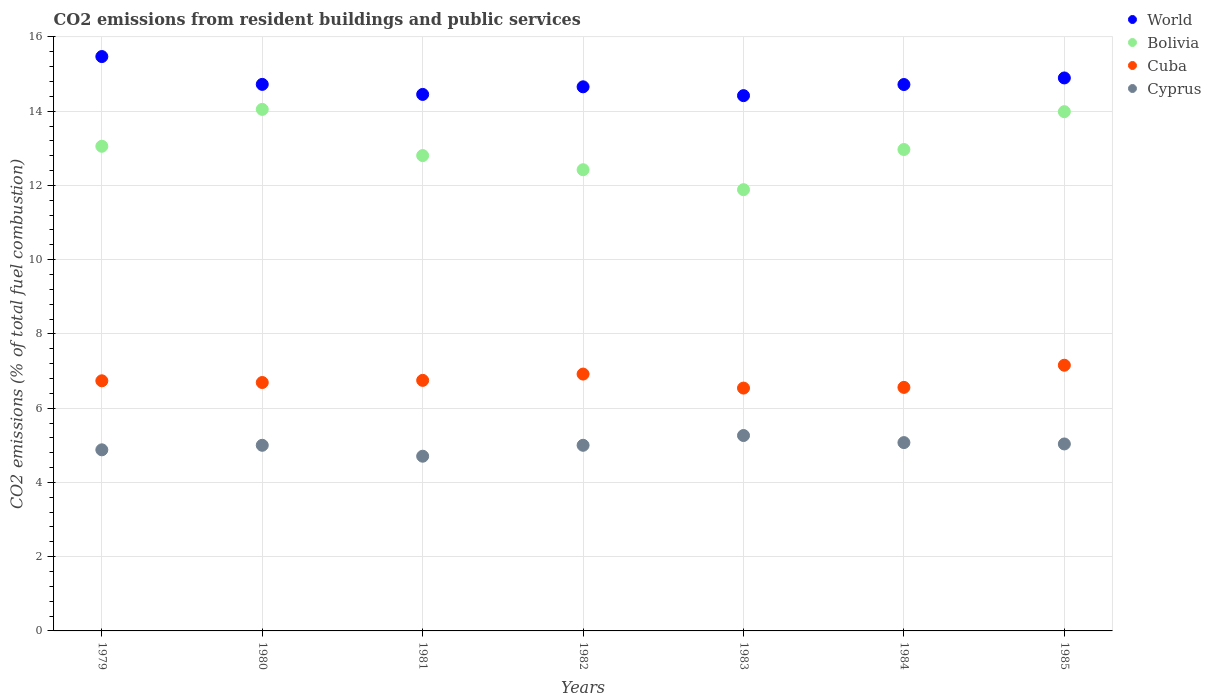Is the number of dotlines equal to the number of legend labels?
Give a very brief answer. Yes. What is the total CO2 emitted in Cyprus in 1982?
Provide a short and direct response. 5. Across all years, what is the maximum total CO2 emitted in Bolivia?
Offer a very short reply. 14.05. Across all years, what is the minimum total CO2 emitted in Cuba?
Provide a succinct answer. 6.54. In which year was the total CO2 emitted in Cyprus maximum?
Ensure brevity in your answer.  1983. What is the total total CO2 emitted in Bolivia in the graph?
Ensure brevity in your answer.  91.17. What is the difference between the total CO2 emitted in World in 1981 and that in 1983?
Your response must be concise. 0.03. What is the difference between the total CO2 emitted in Bolivia in 1985 and the total CO2 emitted in World in 1983?
Offer a terse response. -0.43. What is the average total CO2 emitted in Bolivia per year?
Your answer should be very brief. 13.02. In the year 1980, what is the difference between the total CO2 emitted in Bolivia and total CO2 emitted in World?
Ensure brevity in your answer.  -0.67. In how many years, is the total CO2 emitted in World greater than 5.2?
Your answer should be very brief. 7. What is the ratio of the total CO2 emitted in World in 1981 to that in 1985?
Keep it short and to the point. 0.97. What is the difference between the highest and the second highest total CO2 emitted in World?
Your response must be concise. 0.58. What is the difference between the highest and the lowest total CO2 emitted in Bolivia?
Offer a very short reply. 2.16. In how many years, is the total CO2 emitted in Bolivia greater than the average total CO2 emitted in Bolivia taken over all years?
Provide a succinct answer. 3. Is it the case that in every year, the sum of the total CO2 emitted in World and total CO2 emitted in Cyprus  is greater than the total CO2 emitted in Cuba?
Your answer should be compact. Yes. Does the total CO2 emitted in World monotonically increase over the years?
Keep it short and to the point. No. Is the total CO2 emitted in Cuba strictly less than the total CO2 emitted in Cyprus over the years?
Your answer should be compact. No. How many years are there in the graph?
Offer a very short reply. 7. What is the difference between two consecutive major ticks on the Y-axis?
Your answer should be very brief. 2. Where does the legend appear in the graph?
Your answer should be compact. Top right. What is the title of the graph?
Your response must be concise. CO2 emissions from resident buildings and public services. What is the label or title of the X-axis?
Ensure brevity in your answer.  Years. What is the label or title of the Y-axis?
Give a very brief answer. CO2 emissions (% of total fuel combustion). What is the CO2 emissions (% of total fuel combustion) of World in 1979?
Keep it short and to the point. 15.47. What is the CO2 emissions (% of total fuel combustion) in Bolivia in 1979?
Ensure brevity in your answer.  13.05. What is the CO2 emissions (% of total fuel combustion) in Cuba in 1979?
Give a very brief answer. 6.74. What is the CO2 emissions (% of total fuel combustion) of Cyprus in 1979?
Offer a terse response. 4.88. What is the CO2 emissions (% of total fuel combustion) in World in 1980?
Make the answer very short. 14.72. What is the CO2 emissions (% of total fuel combustion) of Bolivia in 1980?
Your response must be concise. 14.05. What is the CO2 emissions (% of total fuel combustion) in Cuba in 1980?
Your answer should be compact. 6.69. What is the CO2 emissions (% of total fuel combustion) in World in 1981?
Keep it short and to the point. 14.45. What is the CO2 emissions (% of total fuel combustion) of Bolivia in 1981?
Offer a terse response. 12.8. What is the CO2 emissions (% of total fuel combustion) in Cuba in 1981?
Ensure brevity in your answer.  6.75. What is the CO2 emissions (% of total fuel combustion) of Cyprus in 1981?
Your answer should be very brief. 4.71. What is the CO2 emissions (% of total fuel combustion) of World in 1982?
Give a very brief answer. 14.66. What is the CO2 emissions (% of total fuel combustion) of Bolivia in 1982?
Provide a short and direct response. 12.42. What is the CO2 emissions (% of total fuel combustion) of Cuba in 1982?
Your answer should be compact. 6.92. What is the CO2 emissions (% of total fuel combustion) of World in 1983?
Provide a short and direct response. 14.42. What is the CO2 emissions (% of total fuel combustion) in Bolivia in 1983?
Your response must be concise. 11.89. What is the CO2 emissions (% of total fuel combustion) of Cuba in 1983?
Your response must be concise. 6.54. What is the CO2 emissions (% of total fuel combustion) in Cyprus in 1983?
Your response must be concise. 5.26. What is the CO2 emissions (% of total fuel combustion) of World in 1984?
Your response must be concise. 14.72. What is the CO2 emissions (% of total fuel combustion) in Bolivia in 1984?
Ensure brevity in your answer.  12.97. What is the CO2 emissions (% of total fuel combustion) in Cuba in 1984?
Offer a terse response. 6.56. What is the CO2 emissions (% of total fuel combustion) of Cyprus in 1984?
Your response must be concise. 5.07. What is the CO2 emissions (% of total fuel combustion) in World in 1985?
Ensure brevity in your answer.  14.89. What is the CO2 emissions (% of total fuel combustion) of Bolivia in 1985?
Provide a succinct answer. 13.99. What is the CO2 emissions (% of total fuel combustion) of Cuba in 1985?
Give a very brief answer. 7.16. What is the CO2 emissions (% of total fuel combustion) in Cyprus in 1985?
Give a very brief answer. 5.04. Across all years, what is the maximum CO2 emissions (% of total fuel combustion) in World?
Give a very brief answer. 15.47. Across all years, what is the maximum CO2 emissions (% of total fuel combustion) in Bolivia?
Offer a very short reply. 14.05. Across all years, what is the maximum CO2 emissions (% of total fuel combustion) in Cuba?
Your answer should be compact. 7.16. Across all years, what is the maximum CO2 emissions (% of total fuel combustion) in Cyprus?
Provide a succinct answer. 5.26. Across all years, what is the minimum CO2 emissions (% of total fuel combustion) of World?
Give a very brief answer. 14.42. Across all years, what is the minimum CO2 emissions (% of total fuel combustion) in Bolivia?
Make the answer very short. 11.89. Across all years, what is the minimum CO2 emissions (% of total fuel combustion) in Cuba?
Make the answer very short. 6.54. Across all years, what is the minimum CO2 emissions (% of total fuel combustion) of Cyprus?
Make the answer very short. 4.71. What is the total CO2 emissions (% of total fuel combustion) in World in the graph?
Give a very brief answer. 103.33. What is the total CO2 emissions (% of total fuel combustion) of Bolivia in the graph?
Give a very brief answer. 91.17. What is the total CO2 emissions (% of total fuel combustion) of Cuba in the graph?
Ensure brevity in your answer.  47.35. What is the total CO2 emissions (% of total fuel combustion) in Cyprus in the graph?
Provide a succinct answer. 34.96. What is the difference between the CO2 emissions (% of total fuel combustion) in World in 1979 and that in 1980?
Give a very brief answer. 0.75. What is the difference between the CO2 emissions (% of total fuel combustion) in Bolivia in 1979 and that in 1980?
Provide a short and direct response. -0.99. What is the difference between the CO2 emissions (% of total fuel combustion) in Cuba in 1979 and that in 1980?
Your answer should be very brief. 0.05. What is the difference between the CO2 emissions (% of total fuel combustion) in Cyprus in 1979 and that in 1980?
Your answer should be very brief. -0.12. What is the difference between the CO2 emissions (% of total fuel combustion) of World in 1979 and that in 1981?
Your answer should be very brief. 1.02. What is the difference between the CO2 emissions (% of total fuel combustion) in Bolivia in 1979 and that in 1981?
Offer a very short reply. 0.25. What is the difference between the CO2 emissions (% of total fuel combustion) in Cuba in 1979 and that in 1981?
Ensure brevity in your answer.  -0.01. What is the difference between the CO2 emissions (% of total fuel combustion) of Cyprus in 1979 and that in 1981?
Ensure brevity in your answer.  0.17. What is the difference between the CO2 emissions (% of total fuel combustion) in World in 1979 and that in 1982?
Offer a very short reply. 0.82. What is the difference between the CO2 emissions (% of total fuel combustion) in Bolivia in 1979 and that in 1982?
Provide a short and direct response. 0.63. What is the difference between the CO2 emissions (% of total fuel combustion) in Cuba in 1979 and that in 1982?
Offer a very short reply. -0.18. What is the difference between the CO2 emissions (% of total fuel combustion) of Cyprus in 1979 and that in 1982?
Offer a terse response. -0.12. What is the difference between the CO2 emissions (% of total fuel combustion) of World in 1979 and that in 1983?
Your answer should be compact. 1.05. What is the difference between the CO2 emissions (% of total fuel combustion) in Bolivia in 1979 and that in 1983?
Your answer should be compact. 1.17. What is the difference between the CO2 emissions (% of total fuel combustion) of Cuba in 1979 and that in 1983?
Provide a short and direct response. 0.2. What is the difference between the CO2 emissions (% of total fuel combustion) in Cyprus in 1979 and that in 1983?
Offer a terse response. -0.39. What is the difference between the CO2 emissions (% of total fuel combustion) in World in 1979 and that in 1984?
Offer a very short reply. 0.75. What is the difference between the CO2 emissions (% of total fuel combustion) in Bolivia in 1979 and that in 1984?
Offer a terse response. 0.09. What is the difference between the CO2 emissions (% of total fuel combustion) of Cuba in 1979 and that in 1984?
Give a very brief answer. 0.18. What is the difference between the CO2 emissions (% of total fuel combustion) in Cyprus in 1979 and that in 1984?
Give a very brief answer. -0.19. What is the difference between the CO2 emissions (% of total fuel combustion) in World in 1979 and that in 1985?
Make the answer very short. 0.58. What is the difference between the CO2 emissions (% of total fuel combustion) in Bolivia in 1979 and that in 1985?
Give a very brief answer. -0.93. What is the difference between the CO2 emissions (% of total fuel combustion) of Cuba in 1979 and that in 1985?
Offer a very short reply. -0.42. What is the difference between the CO2 emissions (% of total fuel combustion) of Cyprus in 1979 and that in 1985?
Make the answer very short. -0.16. What is the difference between the CO2 emissions (% of total fuel combustion) in World in 1980 and that in 1981?
Provide a succinct answer. 0.27. What is the difference between the CO2 emissions (% of total fuel combustion) of Bolivia in 1980 and that in 1981?
Your answer should be very brief. 1.24. What is the difference between the CO2 emissions (% of total fuel combustion) of Cuba in 1980 and that in 1981?
Offer a terse response. -0.06. What is the difference between the CO2 emissions (% of total fuel combustion) in Cyprus in 1980 and that in 1981?
Your answer should be compact. 0.29. What is the difference between the CO2 emissions (% of total fuel combustion) of World in 1980 and that in 1982?
Ensure brevity in your answer.  0.07. What is the difference between the CO2 emissions (% of total fuel combustion) in Bolivia in 1980 and that in 1982?
Keep it short and to the point. 1.63. What is the difference between the CO2 emissions (% of total fuel combustion) of Cuba in 1980 and that in 1982?
Give a very brief answer. -0.23. What is the difference between the CO2 emissions (% of total fuel combustion) in World in 1980 and that in 1983?
Keep it short and to the point. 0.3. What is the difference between the CO2 emissions (% of total fuel combustion) in Bolivia in 1980 and that in 1983?
Provide a short and direct response. 2.16. What is the difference between the CO2 emissions (% of total fuel combustion) in Cyprus in 1980 and that in 1983?
Keep it short and to the point. -0.26. What is the difference between the CO2 emissions (% of total fuel combustion) of World in 1980 and that in 1984?
Your answer should be compact. 0. What is the difference between the CO2 emissions (% of total fuel combustion) in Bolivia in 1980 and that in 1984?
Offer a very short reply. 1.08. What is the difference between the CO2 emissions (% of total fuel combustion) of Cuba in 1980 and that in 1984?
Your answer should be very brief. 0.13. What is the difference between the CO2 emissions (% of total fuel combustion) of Cyprus in 1980 and that in 1984?
Your answer should be very brief. -0.07. What is the difference between the CO2 emissions (% of total fuel combustion) of World in 1980 and that in 1985?
Ensure brevity in your answer.  -0.17. What is the difference between the CO2 emissions (% of total fuel combustion) in Bolivia in 1980 and that in 1985?
Keep it short and to the point. 0.06. What is the difference between the CO2 emissions (% of total fuel combustion) in Cuba in 1980 and that in 1985?
Your answer should be very brief. -0.47. What is the difference between the CO2 emissions (% of total fuel combustion) in Cyprus in 1980 and that in 1985?
Provide a succinct answer. -0.04. What is the difference between the CO2 emissions (% of total fuel combustion) of World in 1981 and that in 1982?
Offer a terse response. -0.2. What is the difference between the CO2 emissions (% of total fuel combustion) of Bolivia in 1981 and that in 1982?
Provide a succinct answer. 0.38. What is the difference between the CO2 emissions (% of total fuel combustion) in Cuba in 1981 and that in 1982?
Make the answer very short. -0.17. What is the difference between the CO2 emissions (% of total fuel combustion) in Cyprus in 1981 and that in 1982?
Keep it short and to the point. -0.29. What is the difference between the CO2 emissions (% of total fuel combustion) of World in 1981 and that in 1983?
Provide a short and direct response. 0.03. What is the difference between the CO2 emissions (% of total fuel combustion) in Bolivia in 1981 and that in 1983?
Your answer should be very brief. 0.92. What is the difference between the CO2 emissions (% of total fuel combustion) in Cuba in 1981 and that in 1983?
Give a very brief answer. 0.21. What is the difference between the CO2 emissions (% of total fuel combustion) in Cyprus in 1981 and that in 1983?
Offer a very short reply. -0.56. What is the difference between the CO2 emissions (% of total fuel combustion) in World in 1981 and that in 1984?
Your response must be concise. -0.27. What is the difference between the CO2 emissions (% of total fuel combustion) of Bolivia in 1981 and that in 1984?
Provide a succinct answer. -0.16. What is the difference between the CO2 emissions (% of total fuel combustion) of Cuba in 1981 and that in 1984?
Offer a very short reply. 0.19. What is the difference between the CO2 emissions (% of total fuel combustion) in Cyprus in 1981 and that in 1984?
Your answer should be compact. -0.37. What is the difference between the CO2 emissions (% of total fuel combustion) in World in 1981 and that in 1985?
Ensure brevity in your answer.  -0.44. What is the difference between the CO2 emissions (% of total fuel combustion) in Bolivia in 1981 and that in 1985?
Give a very brief answer. -1.18. What is the difference between the CO2 emissions (% of total fuel combustion) in Cuba in 1981 and that in 1985?
Keep it short and to the point. -0.41. What is the difference between the CO2 emissions (% of total fuel combustion) of Cyprus in 1981 and that in 1985?
Provide a succinct answer. -0.33. What is the difference between the CO2 emissions (% of total fuel combustion) in World in 1982 and that in 1983?
Offer a very short reply. 0.24. What is the difference between the CO2 emissions (% of total fuel combustion) in Bolivia in 1982 and that in 1983?
Make the answer very short. 0.54. What is the difference between the CO2 emissions (% of total fuel combustion) in Cuba in 1982 and that in 1983?
Offer a very short reply. 0.38. What is the difference between the CO2 emissions (% of total fuel combustion) of Cyprus in 1982 and that in 1983?
Provide a succinct answer. -0.26. What is the difference between the CO2 emissions (% of total fuel combustion) of World in 1982 and that in 1984?
Offer a very short reply. -0.06. What is the difference between the CO2 emissions (% of total fuel combustion) in Bolivia in 1982 and that in 1984?
Make the answer very short. -0.54. What is the difference between the CO2 emissions (% of total fuel combustion) of Cuba in 1982 and that in 1984?
Provide a succinct answer. 0.36. What is the difference between the CO2 emissions (% of total fuel combustion) of Cyprus in 1982 and that in 1984?
Provide a short and direct response. -0.07. What is the difference between the CO2 emissions (% of total fuel combustion) in World in 1982 and that in 1985?
Offer a terse response. -0.24. What is the difference between the CO2 emissions (% of total fuel combustion) of Bolivia in 1982 and that in 1985?
Your response must be concise. -1.56. What is the difference between the CO2 emissions (% of total fuel combustion) of Cuba in 1982 and that in 1985?
Provide a short and direct response. -0.24. What is the difference between the CO2 emissions (% of total fuel combustion) of Cyprus in 1982 and that in 1985?
Provide a succinct answer. -0.04. What is the difference between the CO2 emissions (% of total fuel combustion) of World in 1983 and that in 1984?
Your answer should be very brief. -0.3. What is the difference between the CO2 emissions (% of total fuel combustion) of Bolivia in 1983 and that in 1984?
Ensure brevity in your answer.  -1.08. What is the difference between the CO2 emissions (% of total fuel combustion) in Cuba in 1983 and that in 1984?
Your answer should be compact. -0.02. What is the difference between the CO2 emissions (% of total fuel combustion) in Cyprus in 1983 and that in 1984?
Offer a very short reply. 0.19. What is the difference between the CO2 emissions (% of total fuel combustion) in World in 1983 and that in 1985?
Offer a terse response. -0.48. What is the difference between the CO2 emissions (% of total fuel combustion) of Bolivia in 1983 and that in 1985?
Keep it short and to the point. -2.1. What is the difference between the CO2 emissions (% of total fuel combustion) of Cuba in 1983 and that in 1985?
Keep it short and to the point. -0.62. What is the difference between the CO2 emissions (% of total fuel combustion) of Cyprus in 1983 and that in 1985?
Ensure brevity in your answer.  0.23. What is the difference between the CO2 emissions (% of total fuel combustion) in World in 1984 and that in 1985?
Offer a terse response. -0.18. What is the difference between the CO2 emissions (% of total fuel combustion) of Bolivia in 1984 and that in 1985?
Keep it short and to the point. -1.02. What is the difference between the CO2 emissions (% of total fuel combustion) in Cuba in 1984 and that in 1985?
Provide a short and direct response. -0.6. What is the difference between the CO2 emissions (% of total fuel combustion) in Cyprus in 1984 and that in 1985?
Offer a terse response. 0.04. What is the difference between the CO2 emissions (% of total fuel combustion) of World in 1979 and the CO2 emissions (% of total fuel combustion) of Bolivia in 1980?
Ensure brevity in your answer.  1.42. What is the difference between the CO2 emissions (% of total fuel combustion) of World in 1979 and the CO2 emissions (% of total fuel combustion) of Cuba in 1980?
Your answer should be very brief. 8.78. What is the difference between the CO2 emissions (% of total fuel combustion) of World in 1979 and the CO2 emissions (% of total fuel combustion) of Cyprus in 1980?
Give a very brief answer. 10.47. What is the difference between the CO2 emissions (% of total fuel combustion) in Bolivia in 1979 and the CO2 emissions (% of total fuel combustion) in Cuba in 1980?
Provide a short and direct response. 6.36. What is the difference between the CO2 emissions (% of total fuel combustion) of Bolivia in 1979 and the CO2 emissions (% of total fuel combustion) of Cyprus in 1980?
Your response must be concise. 8.05. What is the difference between the CO2 emissions (% of total fuel combustion) of Cuba in 1979 and the CO2 emissions (% of total fuel combustion) of Cyprus in 1980?
Keep it short and to the point. 1.74. What is the difference between the CO2 emissions (% of total fuel combustion) of World in 1979 and the CO2 emissions (% of total fuel combustion) of Bolivia in 1981?
Make the answer very short. 2.67. What is the difference between the CO2 emissions (% of total fuel combustion) in World in 1979 and the CO2 emissions (% of total fuel combustion) in Cuba in 1981?
Make the answer very short. 8.72. What is the difference between the CO2 emissions (% of total fuel combustion) of World in 1979 and the CO2 emissions (% of total fuel combustion) of Cyprus in 1981?
Make the answer very short. 10.76. What is the difference between the CO2 emissions (% of total fuel combustion) in Bolivia in 1979 and the CO2 emissions (% of total fuel combustion) in Cuba in 1981?
Your answer should be compact. 6.31. What is the difference between the CO2 emissions (% of total fuel combustion) of Bolivia in 1979 and the CO2 emissions (% of total fuel combustion) of Cyprus in 1981?
Your answer should be compact. 8.35. What is the difference between the CO2 emissions (% of total fuel combustion) in Cuba in 1979 and the CO2 emissions (% of total fuel combustion) in Cyprus in 1981?
Provide a short and direct response. 2.03. What is the difference between the CO2 emissions (% of total fuel combustion) of World in 1979 and the CO2 emissions (% of total fuel combustion) of Bolivia in 1982?
Your answer should be compact. 3.05. What is the difference between the CO2 emissions (% of total fuel combustion) of World in 1979 and the CO2 emissions (% of total fuel combustion) of Cuba in 1982?
Keep it short and to the point. 8.55. What is the difference between the CO2 emissions (% of total fuel combustion) of World in 1979 and the CO2 emissions (% of total fuel combustion) of Cyprus in 1982?
Make the answer very short. 10.47. What is the difference between the CO2 emissions (% of total fuel combustion) in Bolivia in 1979 and the CO2 emissions (% of total fuel combustion) in Cuba in 1982?
Offer a very short reply. 6.14. What is the difference between the CO2 emissions (% of total fuel combustion) in Bolivia in 1979 and the CO2 emissions (% of total fuel combustion) in Cyprus in 1982?
Make the answer very short. 8.05. What is the difference between the CO2 emissions (% of total fuel combustion) of Cuba in 1979 and the CO2 emissions (% of total fuel combustion) of Cyprus in 1982?
Your answer should be very brief. 1.74. What is the difference between the CO2 emissions (% of total fuel combustion) in World in 1979 and the CO2 emissions (% of total fuel combustion) in Bolivia in 1983?
Keep it short and to the point. 3.59. What is the difference between the CO2 emissions (% of total fuel combustion) of World in 1979 and the CO2 emissions (% of total fuel combustion) of Cuba in 1983?
Offer a very short reply. 8.93. What is the difference between the CO2 emissions (% of total fuel combustion) in World in 1979 and the CO2 emissions (% of total fuel combustion) in Cyprus in 1983?
Your answer should be very brief. 10.21. What is the difference between the CO2 emissions (% of total fuel combustion) of Bolivia in 1979 and the CO2 emissions (% of total fuel combustion) of Cuba in 1983?
Keep it short and to the point. 6.51. What is the difference between the CO2 emissions (% of total fuel combustion) in Bolivia in 1979 and the CO2 emissions (% of total fuel combustion) in Cyprus in 1983?
Your answer should be compact. 7.79. What is the difference between the CO2 emissions (% of total fuel combustion) in Cuba in 1979 and the CO2 emissions (% of total fuel combustion) in Cyprus in 1983?
Offer a terse response. 1.47. What is the difference between the CO2 emissions (% of total fuel combustion) in World in 1979 and the CO2 emissions (% of total fuel combustion) in Bolivia in 1984?
Provide a short and direct response. 2.5. What is the difference between the CO2 emissions (% of total fuel combustion) of World in 1979 and the CO2 emissions (% of total fuel combustion) of Cuba in 1984?
Provide a short and direct response. 8.91. What is the difference between the CO2 emissions (% of total fuel combustion) of World in 1979 and the CO2 emissions (% of total fuel combustion) of Cyprus in 1984?
Keep it short and to the point. 10.4. What is the difference between the CO2 emissions (% of total fuel combustion) in Bolivia in 1979 and the CO2 emissions (% of total fuel combustion) in Cuba in 1984?
Offer a very short reply. 6.49. What is the difference between the CO2 emissions (% of total fuel combustion) of Bolivia in 1979 and the CO2 emissions (% of total fuel combustion) of Cyprus in 1984?
Your answer should be very brief. 7.98. What is the difference between the CO2 emissions (% of total fuel combustion) of Cuba in 1979 and the CO2 emissions (% of total fuel combustion) of Cyprus in 1984?
Your answer should be very brief. 1.66. What is the difference between the CO2 emissions (% of total fuel combustion) of World in 1979 and the CO2 emissions (% of total fuel combustion) of Bolivia in 1985?
Keep it short and to the point. 1.48. What is the difference between the CO2 emissions (% of total fuel combustion) of World in 1979 and the CO2 emissions (% of total fuel combustion) of Cuba in 1985?
Your answer should be very brief. 8.31. What is the difference between the CO2 emissions (% of total fuel combustion) of World in 1979 and the CO2 emissions (% of total fuel combustion) of Cyprus in 1985?
Make the answer very short. 10.43. What is the difference between the CO2 emissions (% of total fuel combustion) in Bolivia in 1979 and the CO2 emissions (% of total fuel combustion) in Cuba in 1985?
Your response must be concise. 5.9. What is the difference between the CO2 emissions (% of total fuel combustion) of Bolivia in 1979 and the CO2 emissions (% of total fuel combustion) of Cyprus in 1985?
Provide a short and direct response. 8.02. What is the difference between the CO2 emissions (% of total fuel combustion) in Cuba in 1979 and the CO2 emissions (% of total fuel combustion) in Cyprus in 1985?
Your answer should be very brief. 1.7. What is the difference between the CO2 emissions (% of total fuel combustion) of World in 1980 and the CO2 emissions (% of total fuel combustion) of Bolivia in 1981?
Provide a short and direct response. 1.92. What is the difference between the CO2 emissions (% of total fuel combustion) of World in 1980 and the CO2 emissions (% of total fuel combustion) of Cuba in 1981?
Give a very brief answer. 7.97. What is the difference between the CO2 emissions (% of total fuel combustion) of World in 1980 and the CO2 emissions (% of total fuel combustion) of Cyprus in 1981?
Offer a terse response. 10.02. What is the difference between the CO2 emissions (% of total fuel combustion) of Bolivia in 1980 and the CO2 emissions (% of total fuel combustion) of Cuba in 1981?
Give a very brief answer. 7.3. What is the difference between the CO2 emissions (% of total fuel combustion) in Bolivia in 1980 and the CO2 emissions (% of total fuel combustion) in Cyprus in 1981?
Offer a very short reply. 9.34. What is the difference between the CO2 emissions (% of total fuel combustion) of Cuba in 1980 and the CO2 emissions (% of total fuel combustion) of Cyprus in 1981?
Offer a terse response. 1.99. What is the difference between the CO2 emissions (% of total fuel combustion) of World in 1980 and the CO2 emissions (% of total fuel combustion) of Bolivia in 1982?
Give a very brief answer. 2.3. What is the difference between the CO2 emissions (% of total fuel combustion) in World in 1980 and the CO2 emissions (% of total fuel combustion) in Cuba in 1982?
Provide a succinct answer. 7.8. What is the difference between the CO2 emissions (% of total fuel combustion) of World in 1980 and the CO2 emissions (% of total fuel combustion) of Cyprus in 1982?
Make the answer very short. 9.72. What is the difference between the CO2 emissions (% of total fuel combustion) of Bolivia in 1980 and the CO2 emissions (% of total fuel combustion) of Cuba in 1982?
Your answer should be compact. 7.13. What is the difference between the CO2 emissions (% of total fuel combustion) of Bolivia in 1980 and the CO2 emissions (% of total fuel combustion) of Cyprus in 1982?
Offer a terse response. 9.05. What is the difference between the CO2 emissions (% of total fuel combustion) of Cuba in 1980 and the CO2 emissions (% of total fuel combustion) of Cyprus in 1982?
Provide a short and direct response. 1.69. What is the difference between the CO2 emissions (% of total fuel combustion) in World in 1980 and the CO2 emissions (% of total fuel combustion) in Bolivia in 1983?
Provide a short and direct response. 2.84. What is the difference between the CO2 emissions (% of total fuel combustion) in World in 1980 and the CO2 emissions (% of total fuel combustion) in Cuba in 1983?
Ensure brevity in your answer.  8.18. What is the difference between the CO2 emissions (% of total fuel combustion) in World in 1980 and the CO2 emissions (% of total fuel combustion) in Cyprus in 1983?
Your response must be concise. 9.46. What is the difference between the CO2 emissions (% of total fuel combustion) of Bolivia in 1980 and the CO2 emissions (% of total fuel combustion) of Cuba in 1983?
Your answer should be very brief. 7.51. What is the difference between the CO2 emissions (% of total fuel combustion) of Bolivia in 1980 and the CO2 emissions (% of total fuel combustion) of Cyprus in 1983?
Provide a short and direct response. 8.78. What is the difference between the CO2 emissions (% of total fuel combustion) in Cuba in 1980 and the CO2 emissions (% of total fuel combustion) in Cyprus in 1983?
Your answer should be very brief. 1.43. What is the difference between the CO2 emissions (% of total fuel combustion) in World in 1980 and the CO2 emissions (% of total fuel combustion) in Bolivia in 1984?
Make the answer very short. 1.75. What is the difference between the CO2 emissions (% of total fuel combustion) in World in 1980 and the CO2 emissions (% of total fuel combustion) in Cuba in 1984?
Your answer should be compact. 8.16. What is the difference between the CO2 emissions (% of total fuel combustion) of World in 1980 and the CO2 emissions (% of total fuel combustion) of Cyprus in 1984?
Ensure brevity in your answer.  9.65. What is the difference between the CO2 emissions (% of total fuel combustion) in Bolivia in 1980 and the CO2 emissions (% of total fuel combustion) in Cuba in 1984?
Keep it short and to the point. 7.49. What is the difference between the CO2 emissions (% of total fuel combustion) of Bolivia in 1980 and the CO2 emissions (% of total fuel combustion) of Cyprus in 1984?
Give a very brief answer. 8.98. What is the difference between the CO2 emissions (% of total fuel combustion) in Cuba in 1980 and the CO2 emissions (% of total fuel combustion) in Cyprus in 1984?
Offer a terse response. 1.62. What is the difference between the CO2 emissions (% of total fuel combustion) of World in 1980 and the CO2 emissions (% of total fuel combustion) of Bolivia in 1985?
Keep it short and to the point. 0.74. What is the difference between the CO2 emissions (% of total fuel combustion) in World in 1980 and the CO2 emissions (% of total fuel combustion) in Cuba in 1985?
Offer a terse response. 7.57. What is the difference between the CO2 emissions (% of total fuel combustion) of World in 1980 and the CO2 emissions (% of total fuel combustion) of Cyprus in 1985?
Ensure brevity in your answer.  9.69. What is the difference between the CO2 emissions (% of total fuel combustion) in Bolivia in 1980 and the CO2 emissions (% of total fuel combustion) in Cuba in 1985?
Offer a terse response. 6.89. What is the difference between the CO2 emissions (% of total fuel combustion) in Bolivia in 1980 and the CO2 emissions (% of total fuel combustion) in Cyprus in 1985?
Your answer should be very brief. 9.01. What is the difference between the CO2 emissions (% of total fuel combustion) in Cuba in 1980 and the CO2 emissions (% of total fuel combustion) in Cyprus in 1985?
Provide a short and direct response. 1.66. What is the difference between the CO2 emissions (% of total fuel combustion) in World in 1981 and the CO2 emissions (% of total fuel combustion) in Bolivia in 1982?
Your answer should be very brief. 2.03. What is the difference between the CO2 emissions (% of total fuel combustion) of World in 1981 and the CO2 emissions (% of total fuel combustion) of Cuba in 1982?
Give a very brief answer. 7.53. What is the difference between the CO2 emissions (% of total fuel combustion) in World in 1981 and the CO2 emissions (% of total fuel combustion) in Cyprus in 1982?
Ensure brevity in your answer.  9.45. What is the difference between the CO2 emissions (% of total fuel combustion) of Bolivia in 1981 and the CO2 emissions (% of total fuel combustion) of Cuba in 1982?
Offer a terse response. 5.89. What is the difference between the CO2 emissions (% of total fuel combustion) of Bolivia in 1981 and the CO2 emissions (% of total fuel combustion) of Cyprus in 1982?
Ensure brevity in your answer.  7.8. What is the difference between the CO2 emissions (% of total fuel combustion) of Cuba in 1981 and the CO2 emissions (% of total fuel combustion) of Cyprus in 1982?
Offer a terse response. 1.75. What is the difference between the CO2 emissions (% of total fuel combustion) in World in 1981 and the CO2 emissions (% of total fuel combustion) in Bolivia in 1983?
Your answer should be compact. 2.57. What is the difference between the CO2 emissions (% of total fuel combustion) of World in 1981 and the CO2 emissions (% of total fuel combustion) of Cuba in 1983?
Keep it short and to the point. 7.91. What is the difference between the CO2 emissions (% of total fuel combustion) of World in 1981 and the CO2 emissions (% of total fuel combustion) of Cyprus in 1983?
Your response must be concise. 9.19. What is the difference between the CO2 emissions (% of total fuel combustion) in Bolivia in 1981 and the CO2 emissions (% of total fuel combustion) in Cuba in 1983?
Offer a terse response. 6.26. What is the difference between the CO2 emissions (% of total fuel combustion) in Bolivia in 1981 and the CO2 emissions (% of total fuel combustion) in Cyprus in 1983?
Your response must be concise. 7.54. What is the difference between the CO2 emissions (% of total fuel combustion) in Cuba in 1981 and the CO2 emissions (% of total fuel combustion) in Cyprus in 1983?
Provide a short and direct response. 1.49. What is the difference between the CO2 emissions (% of total fuel combustion) of World in 1981 and the CO2 emissions (% of total fuel combustion) of Bolivia in 1984?
Your answer should be very brief. 1.48. What is the difference between the CO2 emissions (% of total fuel combustion) in World in 1981 and the CO2 emissions (% of total fuel combustion) in Cuba in 1984?
Your answer should be compact. 7.89. What is the difference between the CO2 emissions (% of total fuel combustion) of World in 1981 and the CO2 emissions (% of total fuel combustion) of Cyprus in 1984?
Ensure brevity in your answer.  9.38. What is the difference between the CO2 emissions (% of total fuel combustion) of Bolivia in 1981 and the CO2 emissions (% of total fuel combustion) of Cuba in 1984?
Ensure brevity in your answer.  6.24. What is the difference between the CO2 emissions (% of total fuel combustion) in Bolivia in 1981 and the CO2 emissions (% of total fuel combustion) in Cyprus in 1984?
Provide a succinct answer. 7.73. What is the difference between the CO2 emissions (% of total fuel combustion) in Cuba in 1981 and the CO2 emissions (% of total fuel combustion) in Cyprus in 1984?
Ensure brevity in your answer.  1.68. What is the difference between the CO2 emissions (% of total fuel combustion) of World in 1981 and the CO2 emissions (% of total fuel combustion) of Bolivia in 1985?
Your answer should be very brief. 0.47. What is the difference between the CO2 emissions (% of total fuel combustion) in World in 1981 and the CO2 emissions (% of total fuel combustion) in Cuba in 1985?
Offer a terse response. 7.29. What is the difference between the CO2 emissions (% of total fuel combustion) in World in 1981 and the CO2 emissions (% of total fuel combustion) in Cyprus in 1985?
Ensure brevity in your answer.  9.42. What is the difference between the CO2 emissions (% of total fuel combustion) in Bolivia in 1981 and the CO2 emissions (% of total fuel combustion) in Cuba in 1985?
Your response must be concise. 5.65. What is the difference between the CO2 emissions (% of total fuel combustion) in Bolivia in 1981 and the CO2 emissions (% of total fuel combustion) in Cyprus in 1985?
Give a very brief answer. 7.77. What is the difference between the CO2 emissions (% of total fuel combustion) in Cuba in 1981 and the CO2 emissions (% of total fuel combustion) in Cyprus in 1985?
Offer a terse response. 1.71. What is the difference between the CO2 emissions (% of total fuel combustion) of World in 1982 and the CO2 emissions (% of total fuel combustion) of Bolivia in 1983?
Offer a very short reply. 2.77. What is the difference between the CO2 emissions (% of total fuel combustion) in World in 1982 and the CO2 emissions (% of total fuel combustion) in Cuba in 1983?
Make the answer very short. 8.11. What is the difference between the CO2 emissions (% of total fuel combustion) of World in 1982 and the CO2 emissions (% of total fuel combustion) of Cyprus in 1983?
Provide a short and direct response. 9.39. What is the difference between the CO2 emissions (% of total fuel combustion) of Bolivia in 1982 and the CO2 emissions (% of total fuel combustion) of Cuba in 1983?
Offer a very short reply. 5.88. What is the difference between the CO2 emissions (% of total fuel combustion) in Bolivia in 1982 and the CO2 emissions (% of total fuel combustion) in Cyprus in 1983?
Make the answer very short. 7.16. What is the difference between the CO2 emissions (% of total fuel combustion) of Cuba in 1982 and the CO2 emissions (% of total fuel combustion) of Cyprus in 1983?
Make the answer very short. 1.66. What is the difference between the CO2 emissions (% of total fuel combustion) in World in 1982 and the CO2 emissions (% of total fuel combustion) in Bolivia in 1984?
Keep it short and to the point. 1.69. What is the difference between the CO2 emissions (% of total fuel combustion) in World in 1982 and the CO2 emissions (% of total fuel combustion) in Cuba in 1984?
Your response must be concise. 8.1. What is the difference between the CO2 emissions (% of total fuel combustion) of World in 1982 and the CO2 emissions (% of total fuel combustion) of Cyprus in 1984?
Ensure brevity in your answer.  9.58. What is the difference between the CO2 emissions (% of total fuel combustion) of Bolivia in 1982 and the CO2 emissions (% of total fuel combustion) of Cuba in 1984?
Offer a terse response. 5.86. What is the difference between the CO2 emissions (% of total fuel combustion) in Bolivia in 1982 and the CO2 emissions (% of total fuel combustion) in Cyprus in 1984?
Make the answer very short. 7.35. What is the difference between the CO2 emissions (% of total fuel combustion) of Cuba in 1982 and the CO2 emissions (% of total fuel combustion) of Cyprus in 1984?
Your answer should be very brief. 1.85. What is the difference between the CO2 emissions (% of total fuel combustion) of World in 1982 and the CO2 emissions (% of total fuel combustion) of Bolivia in 1985?
Provide a succinct answer. 0.67. What is the difference between the CO2 emissions (% of total fuel combustion) of World in 1982 and the CO2 emissions (% of total fuel combustion) of Cuba in 1985?
Give a very brief answer. 7.5. What is the difference between the CO2 emissions (% of total fuel combustion) of World in 1982 and the CO2 emissions (% of total fuel combustion) of Cyprus in 1985?
Keep it short and to the point. 9.62. What is the difference between the CO2 emissions (% of total fuel combustion) of Bolivia in 1982 and the CO2 emissions (% of total fuel combustion) of Cuba in 1985?
Offer a very short reply. 5.27. What is the difference between the CO2 emissions (% of total fuel combustion) of Bolivia in 1982 and the CO2 emissions (% of total fuel combustion) of Cyprus in 1985?
Your answer should be very brief. 7.39. What is the difference between the CO2 emissions (% of total fuel combustion) in Cuba in 1982 and the CO2 emissions (% of total fuel combustion) in Cyprus in 1985?
Offer a very short reply. 1.88. What is the difference between the CO2 emissions (% of total fuel combustion) of World in 1983 and the CO2 emissions (% of total fuel combustion) of Bolivia in 1984?
Offer a terse response. 1.45. What is the difference between the CO2 emissions (% of total fuel combustion) in World in 1983 and the CO2 emissions (% of total fuel combustion) in Cuba in 1984?
Make the answer very short. 7.86. What is the difference between the CO2 emissions (% of total fuel combustion) of World in 1983 and the CO2 emissions (% of total fuel combustion) of Cyprus in 1984?
Ensure brevity in your answer.  9.35. What is the difference between the CO2 emissions (% of total fuel combustion) in Bolivia in 1983 and the CO2 emissions (% of total fuel combustion) in Cuba in 1984?
Your answer should be compact. 5.33. What is the difference between the CO2 emissions (% of total fuel combustion) in Bolivia in 1983 and the CO2 emissions (% of total fuel combustion) in Cyprus in 1984?
Provide a succinct answer. 6.81. What is the difference between the CO2 emissions (% of total fuel combustion) of Cuba in 1983 and the CO2 emissions (% of total fuel combustion) of Cyprus in 1984?
Ensure brevity in your answer.  1.47. What is the difference between the CO2 emissions (% of total fuel combustion) in World in 1983 and the CO2 emissions (% of total fuel combustion) in Bolivia in 1985?
Keep it short and to the point. 0.43. What is the difference between the CO2 emissions (% of total fuel combustion) of World in 1983 and the CO2 emissions (% of total fuel combustion) of Cuba in 1985?
Your answer should be very brief. 7.26. What is the difference between the CO2 emissions (% of total fuel combustion) of World in 1983 and the CO2 emissions (% of total fuel combustion) of Cyprus in 1985?
Provide a short and direct response. 9.38. What is the difference between the CO2 emissions (% of total fuel combustion) in Bolivia in 1983 and the CO2 emissions (% of total fuel combustion) in Cuba in 1985?
Offer a very short reply. 4.73. What is the difference between the CO2 emissions (% of total fuel combustion) of Bolivia in 1983 and the CO2 emissions (% of total fuel combustion) of Cyprus in 1985?
Your answer should be compact. 6.85. What is the difference between the CO2 emissions (% of total fuel combustion) in Cuba in 1983 and the CO2 emissions (% of total fuel combustion) in Cyprus in 1985?
Ensure brevity in your answer.  1.5. What is the difference between the CO2 emissions (% of total fuel combustion) in World in 1984 and the CO2 emissions (% of total fuel combustion) in Bolivia in 1985?
Keep it short and to the point. 0.73. What is the difference between the CO2 emissions (% of total fuel combustion) of World in 1984 and the CO2 emissions (% of total fuel combustion) of Cuba in 1985?
Provide a short and direct response. 7.56. What is the difference between the CO2 emissions (% of total fuel combustion) in World in 1984 and the CO2 emissions (% of total fuel combustion) in Cyprus in 1985?
Your answer should be compact. 9.68. What is the difference between the CO2 emissions (% of total fuel combustion) of Bolivia in 1984 and the CO2 emissions (% of total fuel combustion) of Cuba in 1985?
Give a very brief answer. 5.81. What is the difference between the CO2 emissions (% of total fuel combustion) of Bolivia in 1984 and the CO2 emissions (% of total fuel combustion) of Cyprus in 1985?
Your answer should be compact. 7.93. What is the difference between the CO2 emissions (% of total fuel combustion) of Cuba in 1984 and the CO2 emissions (% of total fuel combustion) of Cyprus in 1985?
Offer a very short reply. 1.52. What is the average CO2 emissions (% of total fuel combustion) in World per year?
Keep it short and to the point. 14.76. What is the average CO2 emissions (% of total fuel combustion) of Bolivia per year?
Provide a succinct answer. 13.02. What is the average CO2 emissions (% of total fuel combustion) of Cuba per year?
Provide a succinct answer. 6.76. What is the average CO2 emissions (% of total fuel combustion) of Cyprus per year?
Make the answer very short. 4.99. In the year 1979, what is the difference between the CO2 emissions (% of total fuel combustion) in World and CO2 emissions (% of total fuel combustion) in Bolivia?
Offer a very short reply. 2.42. In the year 1979, what is the difference between the CO2 emissions (% of total fuel combustion) of World and CO2 emissions (% of total fuel combustion) of Cuba?
Your response must be concise. 8.73. In the year 1979, what is the difference between the CO2 emissions (% of total fuel combustion) in World and CO2 emissions (% of total fuel combustion) in Cyprus?
Offer a terse response. 10.59. In the year 1979, what is the difference between the CO2 emissions (% of total fuel combustion) in Bolivia and CO2 emissions (% of total fuel combustion) in Cuba?
Give a very brief answer. 6.32. In the year 1979, what is the difference between the CO2 emissions (% of total fuel combustion) of Bolivia and CO2 emissions (% of total fuel combustion) of Cyprus?
Ensure brevity in your answer.  8.18. In the year 1979, what is the difference between the CO2 emissions (% of total fuel combustion) in Cuba and CO2 emissions (% of total fuel combustion) in Cyprus?
Ensure brevity in your answer.  1.86. In the year 1980, what is the difference between the CO2 emissions (% of total fuel combustion) in World and CO2 emissions (% of total fuel combustion) in Bolivia?
Offer a very short reply. 0.67. In the year 1980, what is the difference between the CO2 emissions (% of total fuel combustion) of World and CO2 emissions (% of total fuel combustion) of Cuba?
Ensure brevity in your answer.  8.03. In the year 1980, what is the difference between the CO2 emissions (% of total fuel combustion) of World and CO2 emissions (% of total fuel combustion) of Cyprus?
Keep it short and to the point. 9.72. In the year 1980, what is the difference between the CO2 emissions (% of total fuel combustion) of Bolivia and CO2 emissions (% of total fuel combustion) of Cuba?
Keep it short and to the point. 7.36. In the year 1980, what is the difference between the CO2 emissions (% of total fuel combustion) of Bolivia and CO2 emissions (% of total fuel combustion) of Cyprus?
Give a very brief answer. 9.05. In the year 1980, what is the difference between the CO2 emissions (% of total fuel combustion) in Cuba and CO2 emissions (% of total fuel combustion) in Cyprus?
Ensure brevity in your answer.  1.69. In the year 1981, what is the difference between the CO2 emissions (% of total fuel combustion) in World and CO2 emissions (% of total fuel combustion) in Bolivia?
Offer a very short reply. 1.65. In the year 1981, what is the difference between the CO2 emissions (% of total fuel combustion) in World and CO2 emissions (% of total fuel combustion) in Cuba?
Give a very brief answer. 7.7. In the year 1981, what is the difference between the CO2 emissions (% of total fuel combustion) of World and CO2 emissions (% of total fuel combustion) of Cyprus?
Offer a very short reply. 9.75. In the year 1981, what is the difference between the CO2 emissions (% of total fuel combustion) of Bolivia and CO2 emissions (% of total fuel combustion) of Cuba?
Provide a short and direct response. 6.05. In the year 1981, what is the difference between the CO2 emissions (% of total fuel combustion) in Bolivia and CO2 emissions (% of total fuel combustion) in Cyprus?
Ensure brevity in your answer.  8.1. In the year 1981, what is the difference between the CO2 emissions (% of total fuel combustion) of Cuba and CO2 emissions (% of total fuel combustion) of Cyprus?
Give a very brief answer. 2.04. In the year 1982, what is the difference between the CO2 emissions (% of total fuel combustion) in World and CO2 emissions (% of total fuel combustion) in Bolivia?
Make the answer very short. 2.23. In the year 1982, what is the difference between the CO2 emissions (% of total fuel combustion) of World and CO2 emissions (% of total fuel combustion) of Cuba?
Provide a succinct answer. 7.74. In the year 1982, what is the difference between the CO2 emissions (% of total fuel combustion) of World and CO2 emissions (% of total fuel combustion) of Cyprus?
Ensure brevity in your answer.  9.66. In the year 1982, what is the difference between the CO2 emissions (% of total fuel combustion) of Bolivia and CO2 emissions (% of total fuel combustion) of Cuba?
Offer a very short reply. 5.5. In the year 1982, what is the difference between the CO2 emissions (% of total fuel combustion) of Bolivia and CO2 emissions (% of total fuel combustion) of Cyprus?
Make the answer very short. 7.42. In the year 1982, what is the difference between the CO2 emissions (% of total fuel combustion) in Cuba and CO2 emissions (% of total fuel combustion) in Cyprus?
Your answer should be very brief. 1.92. In the year 1983, what is the difference between the CO2 emissions (% of total fuel combustion) of World and CO2 emissions (% of total fuel combustion) of Bolivia?
Offer a terse response. 2.53. In the year 1983, what is the difference between the CO2 emissions (% of total fuel combustion) of World and CO2 emissions (% of total fuel combustion) of Cuba?
Offer a terse response. 7.88. In the year 1983, what is the difference between the CO2 emissions (% of total fuel combustion) in World and CO2 emissions (% of total fuel combustion) in Cyprus?
Your answer should be compact. 9.15. In the year 1983, what is the difference between the CO2 emissions (% of total fuel combustion) of Bolivia and CO2 emissions (% of total fuel combustion) of Cuba?
Ensure brevity in your answer.  5.34. In the year 1983, what is the difference between the CO2 emissions (% of total fuel combustion) of Bolivia and CO2 emissions (% of total fuel combustion) of Cyprus?
Give a very brief answer. 6.62. In the year 1983, what is the difference between the CO2 emissions (% of total fuel combustion) in Cuba and CO2 emissions (% of total fuel combustion) in Cyprus?
Keep it short and to the point. 1.28. In the year 1984, what is the difference between the CO2 emissions (% of total fuel combustion) of World and CO2 emissions (% of total fuel combustion) of Bolivia?
Provide a short and direct response. 1.75. In the year 1984, what is the difference between the CO2 emissions (% of total fuel combustion) of World and CO2 emissions (% of total fuel combustion) of Cuba?
Give a very brief answer. 8.16. In the year 1984, what is the difference between the CO2 emissions (% of total fuel combustion) in World and CO2 emissions (% of total fuel combustion) in Cyprus?
Make the answer very short. 9.65. In the year 1984, what is the difference between the CO2 emissions (% of total fuel combustion) of Bolivia and CO2 emissions (% of total fuel combustion) of Cuba?
Provide a short and direct response. 6.41. In the year 1984, what is the difference between the CO2 emissions (% of total fuel combustion) of Bolivia and CO2 emissions (% of total fuel combustion) of Cyprus?
Ensure brevity in your answer.  7.89. In the year 1984, what is the difference between the CO2 emissions (% of total fuel combustion) of Cuba and CO2 emissions (% of total fuel combustion) of Cyprus?
Your response must be concise. 1.49. In the year 1985, what is the difference between the CO2 emissions (% of total fuel combustion) in World and CO2 emissions (% of total fuel combustion) in Bolivia?
Offer a very short reply. 0.91. In the year 1985, what is the difference between the CO2 emissions (% of total fuel combustion) in World and CO2 emissions (% of total fuel combustion) in Cuba?
Offer a terse response. 7.74. In the year 1985, what is the difference between the CO2 emissions (% of total fuel combustion) in World and CO2 emissions (% of total fuel combustion) in Cyprus?
Offer a terse response. 9.86. In the year 1985, what is the difference between the CO2 emissions (% of total fuel combustion) in Bolivia and CO2 emissions (% of total fuel combustion) in Cuba?
Give a very brief answer. 6.83. In the year 1985, what is the difference between the CO2 emissions (% of total fuel combustion) of Bolivia and CO2 emissions (% of total fuel combustion) of Cyprus?
Make the answer very short. 8.95. In the year 1985, what is the difference between the CO2 emissions (% of total fuel combustion) of Cuba and CO2 emissions (% of total fuel combustion) of Cyprus?
Ensure brevity in your answer.  2.12. What is the ratio of the CO2 emissions (% of total fuel combustion) of World in 1979 to that in 1980?
Offer a very short reply. 1.05. What is the ratio of the CO2 emissions (% of total fuel combustion) of Bolivia in 1979 to that in 1980?
Provide a succinct answer. 0.93. What is the ratio of the CO2 emissions (% of total fuel combustion) in Cuba in 1979 to that in 1980?
Provide a succinct answer. 1.01. What is the ratio of the CO2 emissions (% of total fuel combustion) of Cyprus in 1979 to that in 1980?
Keep it short and to the point. 0.98. What is the ratio of the CO2 emissions (% of total fuel combustion) of World in 1979 to that in 1981?
Your response must be concise. 1.07. What is the ratio of the CO2 emissions (% of total fuel combustion) in Bolivia in 1979 to that in 1981?
Your response must be concise. 1.02. What is the ratio of the CO2 emissions (% of total fuel combustion) of Cuba in 1979 to that in 1981?
Provide a short and direct response. 1. What is the ratio of the CO2 emissions (% of total fuel combustion) of Cyprus in 1979 to that in 1981?
Your answer should be compact. 1.04. What is the ratio of the CO2 emissions (% of total fuel combustion) of World in 1979 to that in 1982?
Keep it short and to the point. 1.06. What is the ratio of the CO2 emissions (% of total fuel combustion) of Bolivia in 1979 to that in 1982?
Ensure brevity in your answer.  1.05. What is the ratio of the CO2 emissions (% of total fuel combustion) in Cuba in 1979 to that in 1982?
Ensure brevity in your answer.  0.97. What is the ratio of the CO2 emissions (% of total fuel combustion) in Cyprus in 1979 to that in 1982?
Offer a very short reply. 0.98. What is the ratio of the CO2 emissions (% of total fuel combustion) in World in 1979 to that in 1983?
Ensure brevity in your answer.  1.07. What is the ratio of the CO2 emissions (% of total fuel combustion) of Bolivia in 1979 to that in 1983?
Provide a short and direct response. 1.1. What is the ratio of the CO2 emissions (% of total fuel combustion) of Cyprus in 1979 to that in 1983?
Your response must be concise. 0.93. What is the ratio of the CO2 emissions (% of total fuel combustion) in World in 1979 to that in 1984?
Keep it short and to the point. 1.05. What is the ratio of the CO2 emissions (% of total fuel combustion) of Cyprus in 1979 to that in 1984?
Your response must be concise. 0.96. What is the ratio of the CO2 emissions (% of total fuel combustion) of World in 1979 to that in 1985?
Give a very brief answer. 1.04. What is the ratio of the CO2 emissions (% of total fuel combustion) of Bolivia in 1979 to that in 1985?
Keep it short and to the point. 0.93. What is the ratio of the CO2 emissions (% of total fuel combustion) in Cuba in 1979 to that in 1985?
Provide a succinct answer. 0.94. What is the ratio of the CO2 emissions (% of total fuel combustion) in Cyprus in 1979 to that in 1985?
Provide a short and direct response. 0.97. What is the ratio of the CO2 emissions (% of total fuel combustion) of World in 1980 to that in 1981?
Give a very brief answer. 1.02. What is the ratio of the CO2 emissions (% of total fuel combustion) of Bolivia in 1980 to that in 1981?
Provide a succinct answer. 1.1. What is the ratio of the CO2 emissions (% of total fuel combustion) of Cyprus in 1980 to that in 1981?
Your answer should be compact. 1.06. What is the ratio of the CO2 emissions (% of total fuel combustion) of World in 1980 to that in 1982?
Offer a very short reply. 1. What is the ratio of the CO2 emissions (% of total fuel combustion) in Bolivia in 1980 to that in 1982?
Ensure brevity in your answer.  1.13. What is the ratio of the CO2 emissions (% of total fuel combustion) in Cuba in 1980 to that in 1982?
Your answer should be compact. 0.97. What is the ratio of the CO2 emissions (% of total fuel combustion) in Cyprus in 1980 to that in 1982?
Keep it short and to the point. 1. What is the ratio of the CO2 emissions (% of total fuel combustion) of Bolivia in 1980 to that in 1983?
Make the answer very short. 1.18. What is the ratio of the CO2 emissions (% of total fuel combustion) in Cuba in 1980 to that in 1983?
Offer a terse response. 1.02. What is the ratio of the CO2 emissions (% of total fuel combustion) of Cyprus in 1980 to that in 1983?
Provide a succinct answer. 0.95. What is the ratio of the CO2 emissions (% of total fuel combustion) of Bolivia in 1980 to that in 1984?
Your answer should be compact. 1.08. What is the ratio of the CO2 emissions (% of total fuel combustion) of Cuba in 1980 to that in 1984?
Give a very brief answer. 1.02. What is the ratio of the CO2 emissions (% of total fuel combustion) in Cyprus in 1980 to that in 1984?
Your answer should be very brief. 0.99. What is the ratio of the CO2 emissions (% of total fuel combustion) in World in 1980 to that in 1985?
Give a very brief answer. 0.99. What is the ratio of the CO2 emissions (% of total fuel combustion) of Bolivia in 1980 to that in 1985?
Provide a succinct answer. 1. What is the ratio of the CO2 emissions (% of total fuel combustion) in Cuba in 1980 to that in 1985?
Your answer should be compact. 0.94. What is the ratio of the CO2 emissions (% of total fuel combustion) of World in 1981 to that in 1982?
Give a very brief answer. 0.99. What is the ratio of the CO2 emissions (% of total fuel combustion) in Bolivia in 1981 to that in 1982?
Keep it short and to the point. 1.03. What is the ratio of the CO2 emissions (% of total fuel combustion) of Cuba in 1981 to that in 1982?
Your answer should be very brief. 0.98. What is the ratio of the CO2 emissions (% of total fuel combustion) of World in 1981 to that in 1983?
Your answer should be very brief. 1. What is the ratio of the CO2 emissions (% of total fuel combustion) in Bolivia in 1981 to that in 1983?
Offer a terse response. 1.08. What is the ratio of the CO2 emissions (% of total fuel combustion) in Cuba in 1981 to that in 1983?
Your answer should be compact. 1.03. What is the ratio of the CO2 emissions (% of total fuel combustion) in Cyprus in 1981 to that in 1983?
Give a very brief answer. 0.89. What is the ratio of the CO2 emissions (% of total fuel combustion) of World in 1981 to that in 1984?
Ensure brevity in your answer.  0.98. What is the ratio of the CO2 emissions (% of total fuel combustion) of Bolivia in 1981 to that in 1984?
Your response must be concise. 0.99. What is the ratio of the CO2 emissions (% of total fuel combustion) in Cuba in 1981 to that in 1984?
Make the answer very short. 1.03. What is the ratio of the CO2 emissions (% of total fuel combustion) of Cyprus in 1981 to that in 1984?
Make the answer very short. 0.93. What is the ratio of the CO2 emissions (% of total fuel combustion) of World in 1981 to that in 1985?
Offer a very short reply. 0.97. What is the ratio of the CO2 emissions (% of total fuel combustion) of Bolivia in 1981 to that in 1985?
Give a very brief answer. 0.92. What is the ratio of the CO2 emissions (% of total fuel combustion) in Cuba in 1981 to that in 1985?
Keep it short and to the point. 0.94. What is the ratio of the CO2 emissions (% of total fuel combustion) in Cyprus in 1981 to that in 1985?
Offer a terse response. 0.93. What is the ratio of the CO2 emissions (% of total fuel combustion) in World in 1982 to that in 1983?
Provide a succinct answer. 1.02. What is the ratio of the CO2 emissions (% of total fuel combustion) of Bolivia in 1982 to that in 1983?
Give a very brief answer. 1.05. What is the ratio of the CO2 emissions (% of total fuel combustion) in Cuba in 1982 to that in 1983?
Keep it short and to the point. 1.06. What is the ratio of the CO2 emissions (% of total fuel combustion) of Bolivia in 1982 to that in 1984?
Your answer should be compact. 0.96. What is the ratio of the CO2 emissions (% of total fuel combustion) of Cuba in 1982 to that in 1984?
Your response must be concise. 1.05. What is the ratio of the CO2 emissions (% of total fuel combustion) of Cyprus in 1982 to that in 1984?
Give a very brief answer. 0.99. What is the ratio of the CO2 emissions (% of total fuel combustion) in Bolivia in 1982 to that in 1985?
Your answer should be very brief. 0.89. What is the ratio of the CO2 emissions (% of total fuel combustion) in Cuba in 1982 to that in 1985?
Offer a terse response. 0.97. What is the ratio of the CO2 emissions (% of total fuel combustion) in Cyprus in 1982 to that in 1985?
Keep it short and to the point. 0.99. What is the ratio of the CO2 emissions (% of total fuel combustion) of World in 1983 to that in 1984?
Offer a terse response. 0.98. What is the ratio of the CO2 emissions (% of total fuel combustion) of Bolivia in 1983 to that in 1984?
Make the answer very short. 0.92. What is the ratio of the CO2 emissions (% of total fuel combustion) in Cuba in 1983 to that in 1984?
Offer a terse response. 1. What is the ratio of the CO2 emissions (% of total fuel combustion) of Cyprus in 1983 to that in 1984?
Provide a succinct answer. 1.04. What is the ratio of the CO2 emissions (% of total fuel combustion) in Bolivia in 1983 to that in 1985?
Provide a short and direct response. 0.85. What is the ratio of the CO2 emissions (% of total fuel combustion) of Cuba in 1983 to that in 1985?
Offer a very short reply. 0.91. What is the ratio of the CO2 emissions (% of total fuel combustion) of Cyprus in 1983 to that in 1985?
Keep it short and to the point. 1.05. What is the ratio of the CO2 emissions (% of total fuel combustion) in World in 1984 to that in 1985?
Your response must be concise. 0.99. What is the ratio of the CO2 emissions (% of total fuel combustion) of Bolivia in 1984 to that in 1985?
Keep it short and to the point. 0.93. What is the ratio of the CO2 emissions (% of total fuel combustion) of Cuba in 1984 to that in 1985?
Give a very brief answer. 0.92. What is the difference between the highest and the second highest CO2 emissions (% of total fuel combustion) of World?
Offer a terse response. 0.58. What is the difference between the highest and the second highest CO2 emissions (% of total fuel combustion) in Bolivia?
Ensure brevity in your answer.  0.06. What is the difference between the highest and the second highest CO2 emissions (% of total fuel combustion) in Cuba?
Your response must be concise. 0.24. What is the difference between the highest and the second highest CO2 emissions (% of total fuel combustion) in Cyprus?
Offer a terse response. 0.19. What is the difference between the highest and the lowest CO2 emissions (% of total fuel combustion) in World?
Your response must be concise. 1.05. What is the difference between the highest and the lowest CO2 emissions (% of total fuel combustion) in Bolivia?
Your answer should be very brief. 2.16. What is the difference between the highest and the lowest CO2 emissions (% of total fuel combustion) in Cuba?
Give a very brief answer. 0.62. What is the difference between the highest and the lowest CO2 emissions (% of total fuel combustion) of Cyprus?
Give a very brief answer. 0.56. 